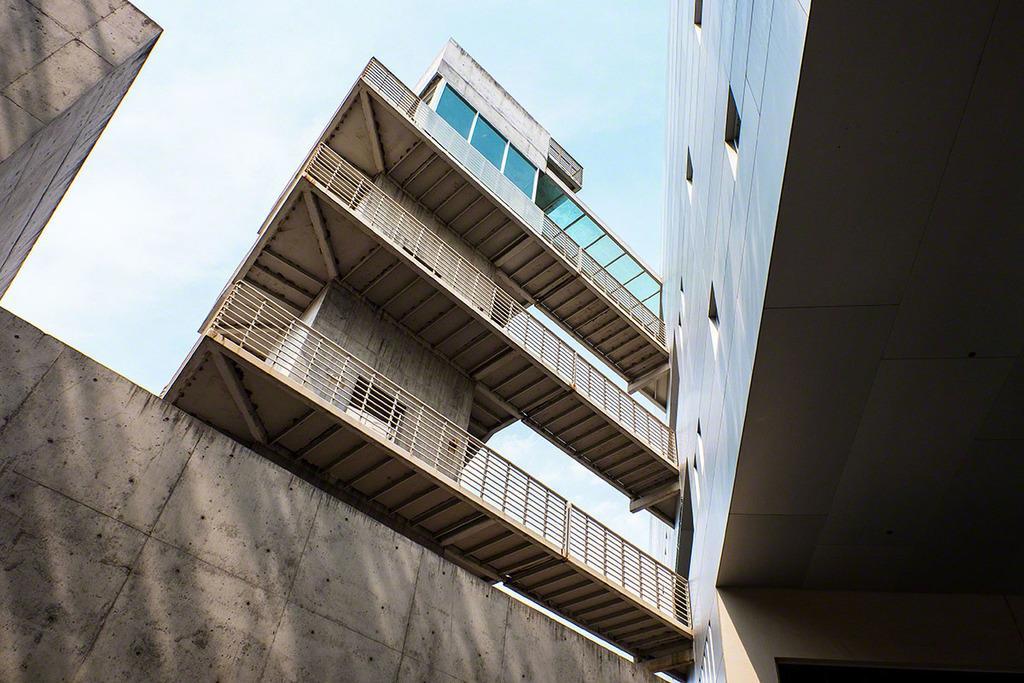Please provide a concise description of this image. This picture shows couple of buildings and we see a wall and a blue cloudy sky. 